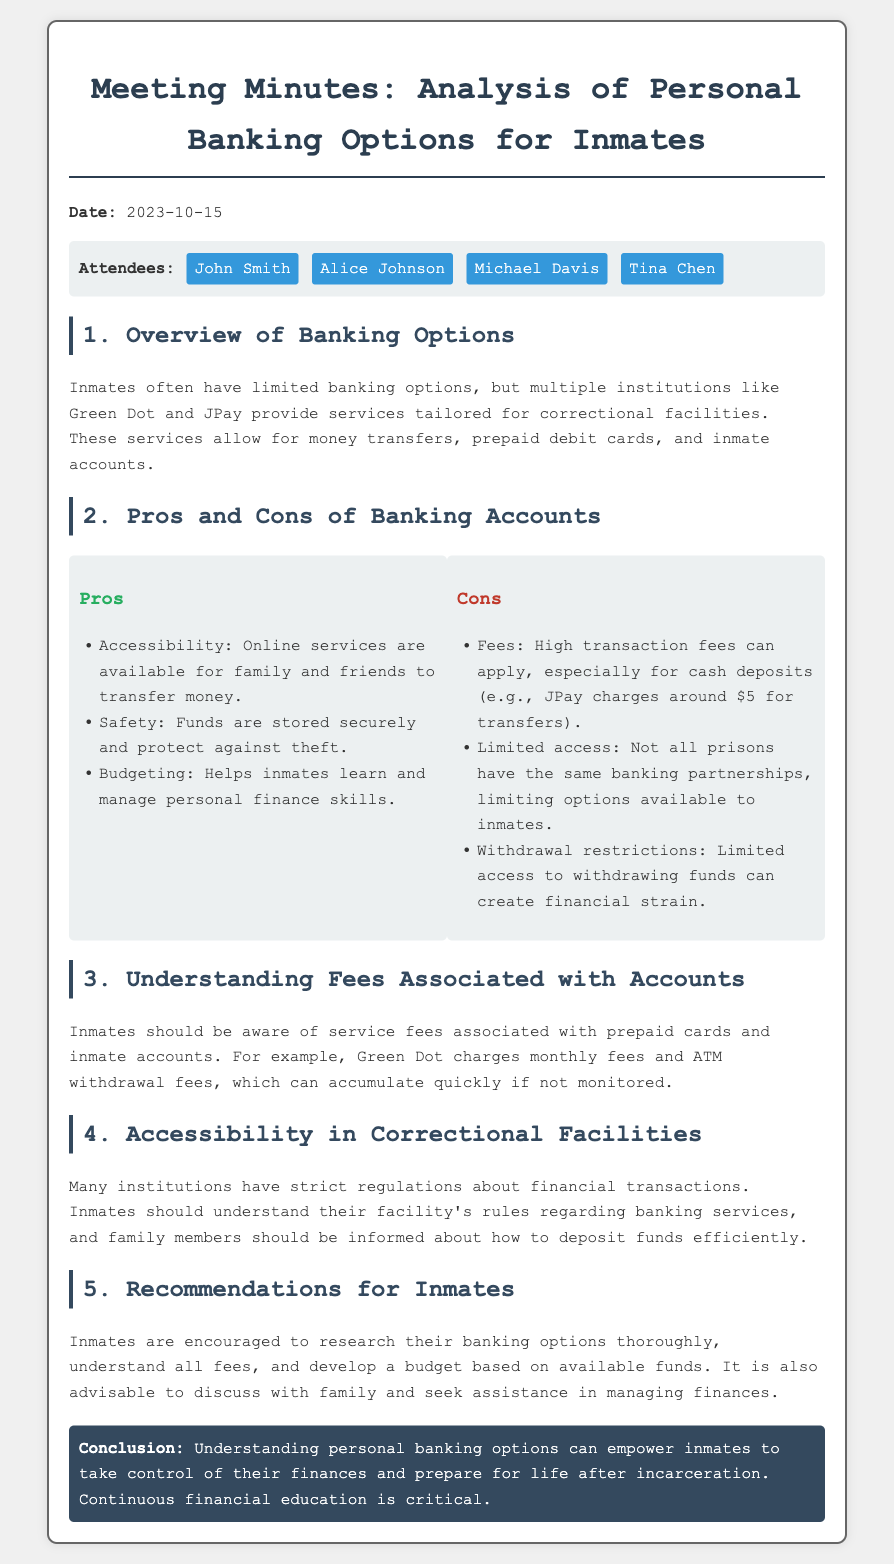What is the date of the meeting? The date mentioned in the document is 2023-10-15.
Answer: 2023-10-15 Who is one of the attendees at the meeting? The document lists attendees including John Smith, Alice Johnson, Michael Davis, and Tina Chen.
Answer: John Smith What is one banking option mentioned for inmates? The document states that institutions like Green Dot and JPay provide services tailored for correctional facilities.
Answer: Green Dot What is a con of banking accounts mentioned in the document? The cons section lists that high transaction fees can apply, especially for cash deposits.
Answer: High transaction fees What fee does JPay charge for transfers? The document mentions that JPay charges around $5 for transfers.
Answer: $5 What is one recommendation for inmates regarding banking options? The document advises inmates to research their banking options thoroughly to know about fees.
Answer: Research banking options How many pros are listed for banking accounts? The document includes three advantages in the pros section of banking accounts.
Answer: Three What is the main conclusion of the meeting? The document summarizes that understanding personal banking options can empower inmates regarding their finances.
Answer: Empower inmates to take control 